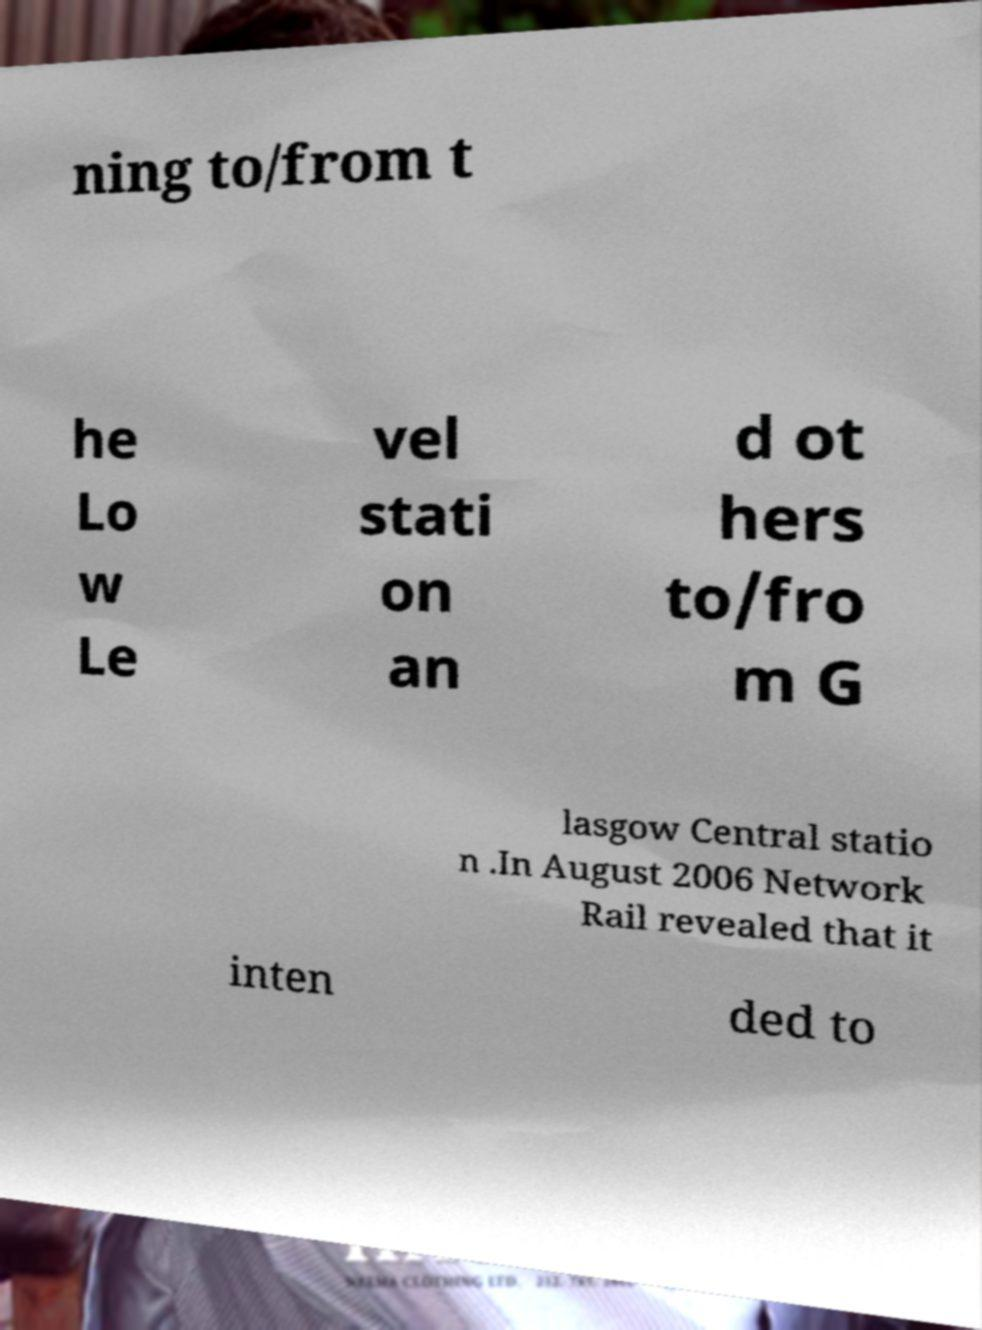Please read and relay the text visible in this image. What does it say? ning to/from t he Lo w Le vel stati on an d ot hers to/fro m G lasgow Central statio n .In August 2006 Network Rail revealed that it inten ded to 